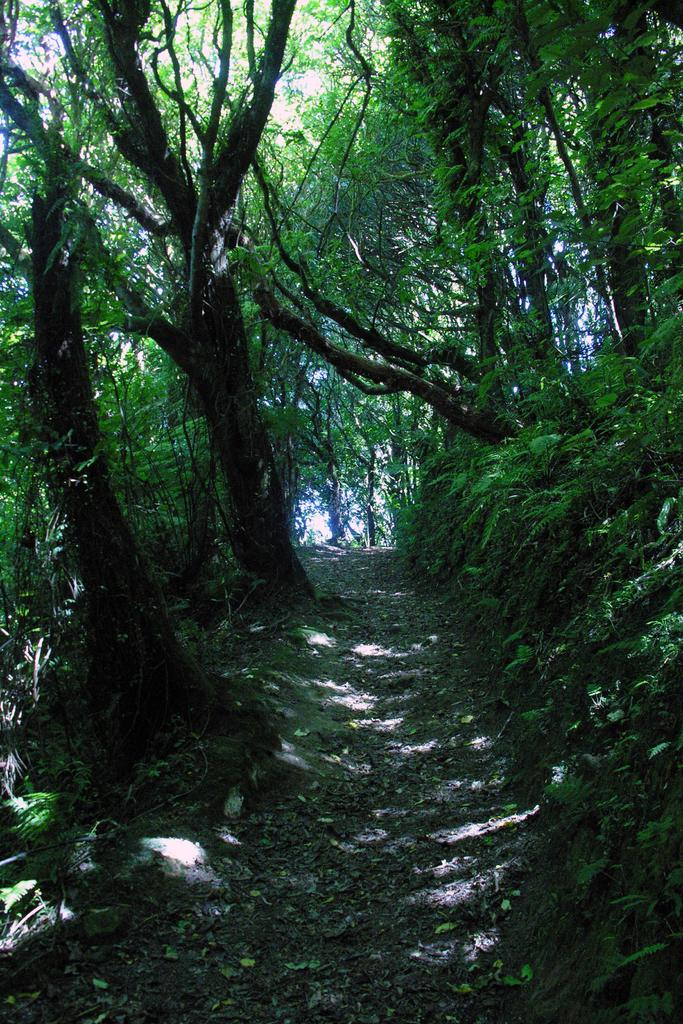What is present on the ground in the image? There are dry leaves on the ground in the image. What type of vegetation is visible in the image? There are a lot of trees in the image. What type of screw can be seen holding the railway in the image? There is no screw or railway present in the image; it features dry leaves on the ground and trees. What type of cake is visible on the trees in the image? There is no cake present in the image; it features dry leaves on the ground and trees. 